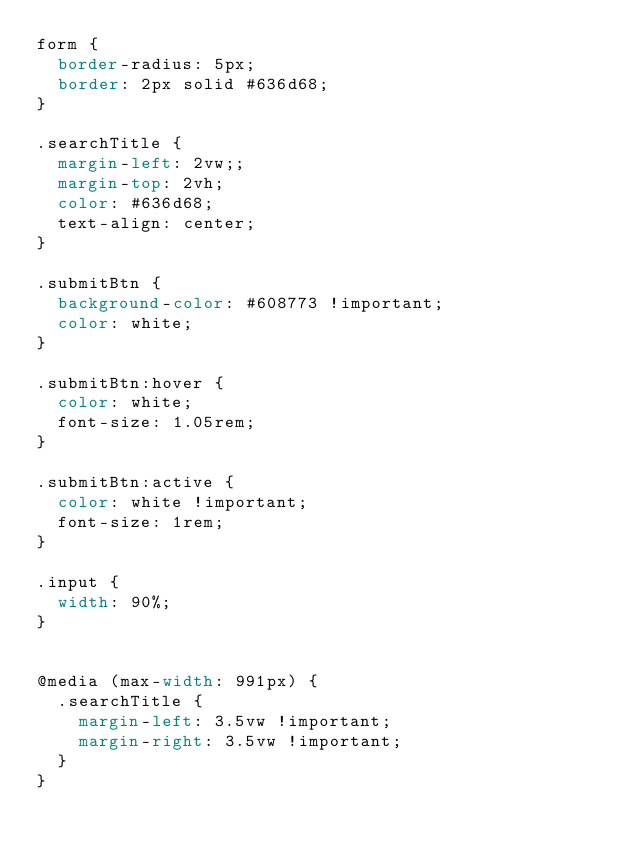<code> <loc_0><loc_0><loc_500><loc_500><_CSS_>form {
  border-radius: 5px;
  border: 2px solid #636d68;
}

.searchTitle {
  margin-left: 2vw;;
  margin-top: 2vh;
  color: #636d68;
  text-align: center;
}

.submitBtn {
  background-color: #608773 !important;
  color: white;
}

.submitBtn:hover {
  color: white;
  font-size: 1.05rem;
}

.submitBtn:active {
  color: white !important;
  font-size: 1rem;
}

.input {
  width: 90%;
}


@media (max-width: 991px) {
  .searchTitle {
    margin-left: 3.5vw !important;
    margin-right: 3.5vw !important;
  }
}
</code> 